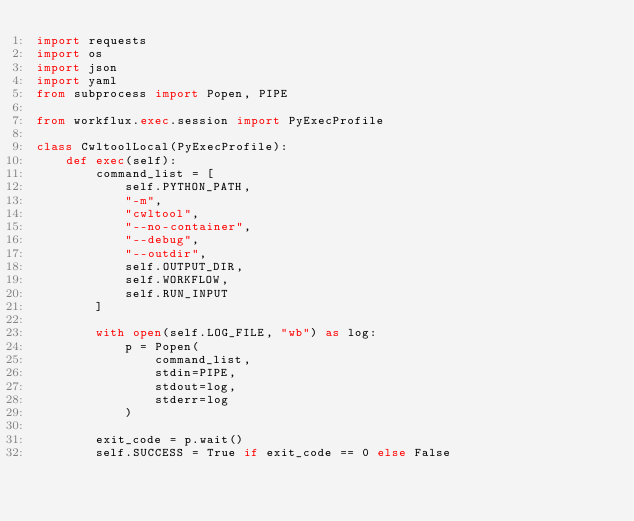Convert code to text. <code><loc_0><loc_0><loc_500><loc_500><_Python_>import requests
import os
import json
import yaml
from subprocess import Popen, PIPE

from workflux.exec.session import PyExecProfile

class CwltoolLocal(PyExecProfile):
    def exec(self):
        command_list = [
            self.PYTHON_PATH,
            "-m",
            "cwltool",
            "--no-container",
            "--debug",
            "--outdir",
            self.OUTPUT_DIR,
            self.WORKFLOW,
            self.RUN_INPUT
        ]

        with open(self.LOG_FILE, "wb") as log:
            p = Popen(
                command_list, 
                stdin=PIPE,
                stdout=log,
                stderr=log
            )
        
        exit_code = p.wait()
        self.SUCCESS = True if exit_code == 0 else False</code> 